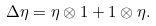<formula> <loc_0><loc_0><loc_500><loc_500>\Delta \eta = \eta \otimes 1 + 1 \otimes \eta .</formula> 